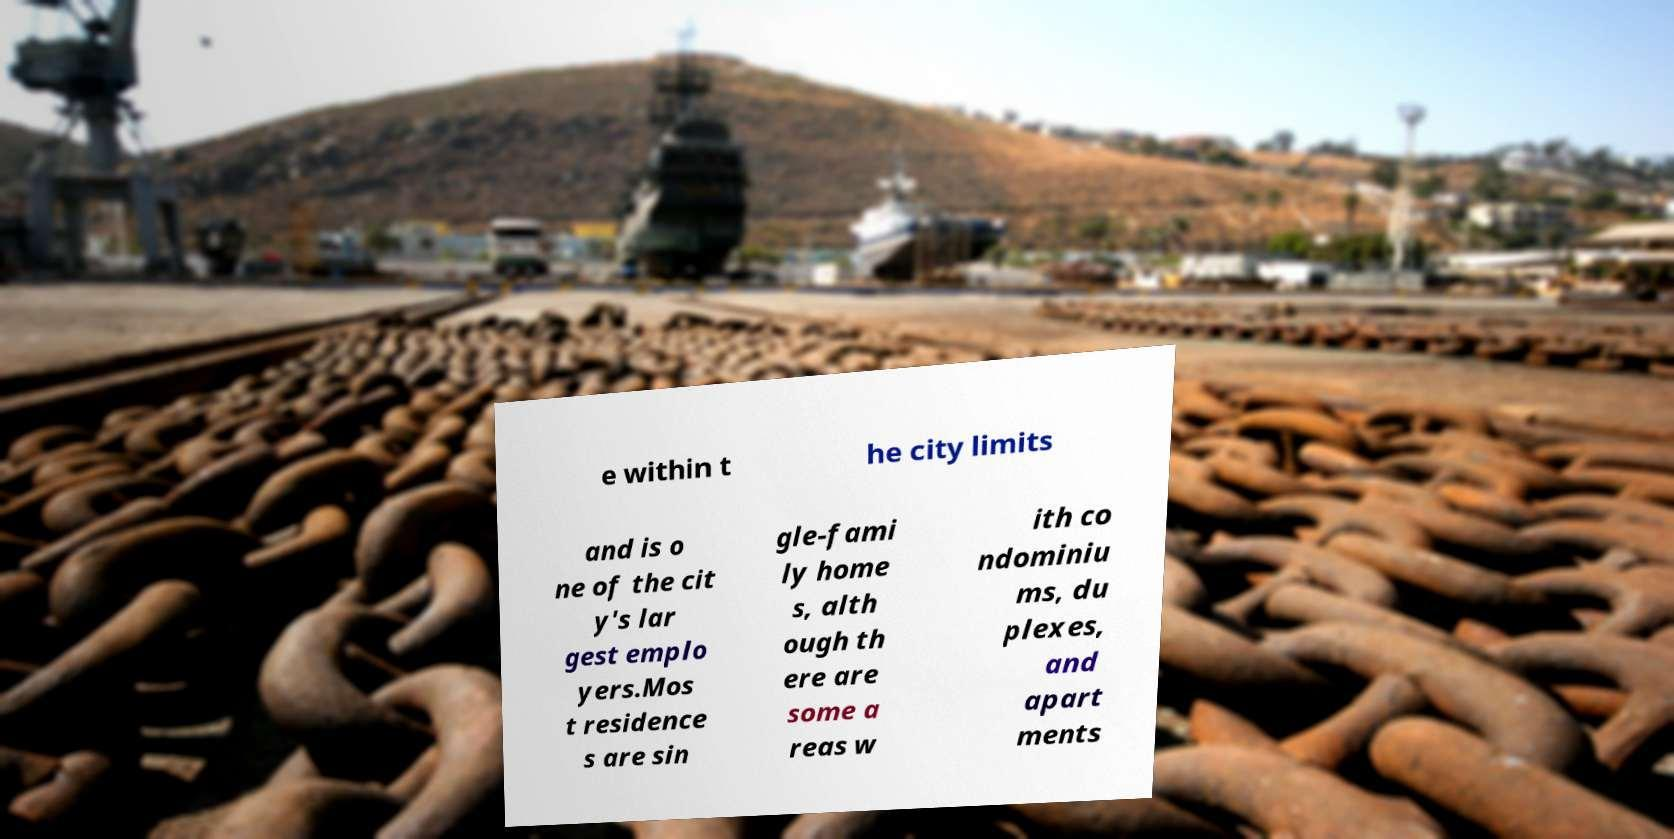Please read and relay the text visible in this image. What does it say? e within t he city limits and is o ne of the cit y's lar gest emplo yers.Mos t residence s are sin gle-fami ly home s, alth ough th ere are some a reas w ith co ndominiu ms, du plexes, and apart ments 